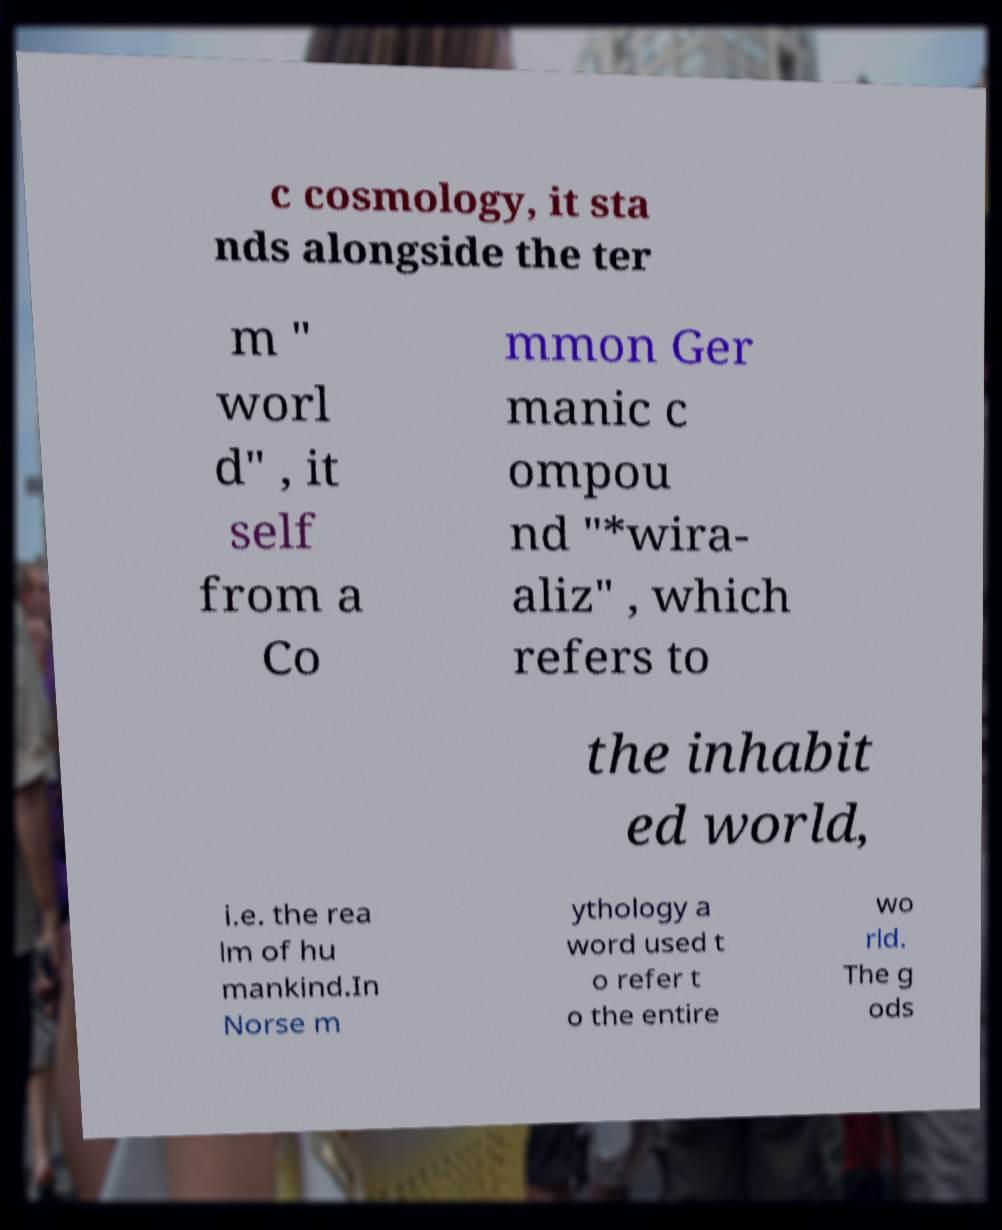For documentation purposes, I need the text within this image transcribed. Could you provide that? c cosmology, it sta nds alongside the ter m " worl d" , it self from a Co mmon Ger manic c ompou nd "*wira- aliz" , which refers to the inhabit ed world, i.e. the rea lm of hu mankind.In Norse m ythology a word used t o refer t o the entire wo rld. The g ods 